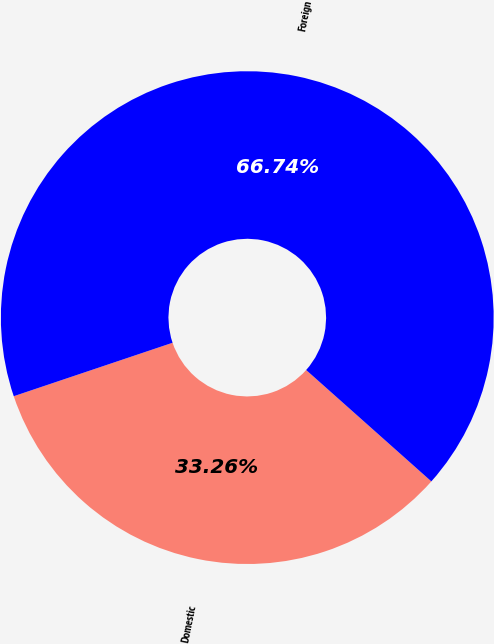Convert chart. <chart><loc_0><loc_0><loc_500><loc_500><pie_chart><fcel>Domestic<fcel>Foreign<nl><fcel>33.26%<fcel>66.74%<nl></chart> 